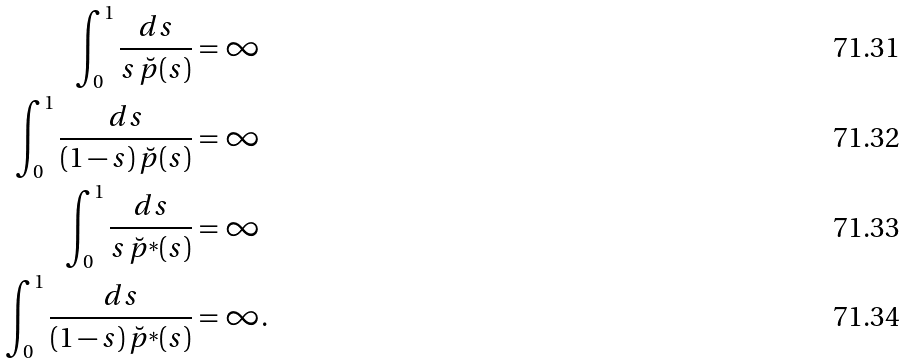Convert formula to latex. <formula><loc_0><loc_0><loc_500><loc_500>\int _ { 0 } ^ { 1 } \frac { d s } { s \, \breve { p } ( s ) } & = \infty \\ \int _ { 0 } ^ { 1 } \frac { d s } { ( 1 - s ) \, \breve { p } ( s ) } & = \infty \\ \int _ { 0 } ^ { 1 } \frac { d s } { s \, \breve { p } ^ { * } ( s ) } & = \infty \\ \int _ { 0 } ^ { 1 } \frac { d s } { ( 1 - s ) \, \breve { p } ^ { * } ( s ) } & = \infty .</formula> 